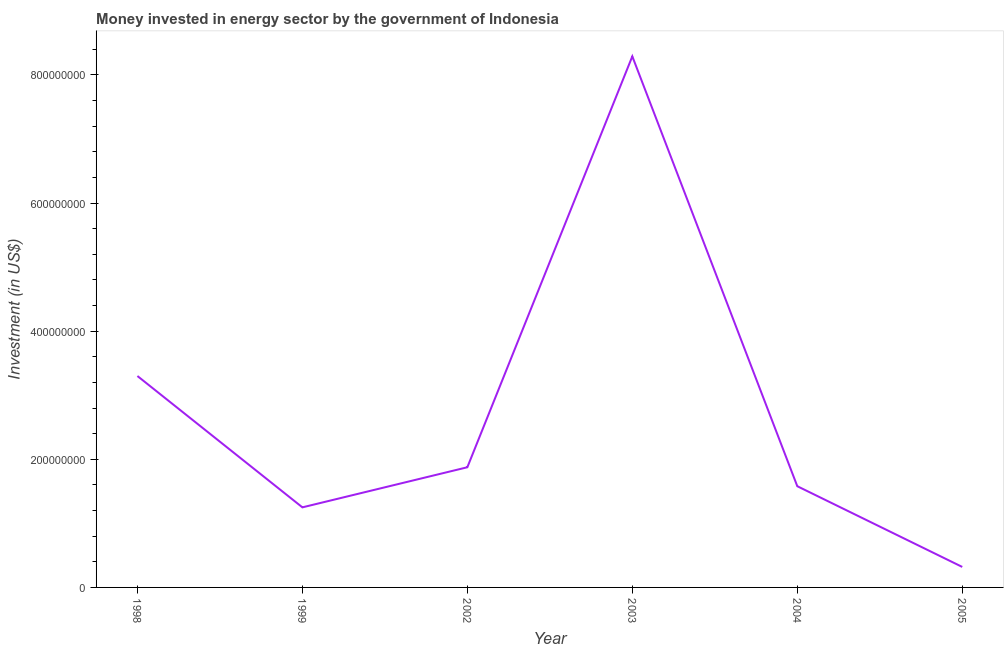What is the investment in energy in 1998?
Provide a short and direct response. 3.30e+08. Across all years, what is the maximum investment in energy?
Provide a short and direct response. 8.29e+08. Across all years, what is the minimum investment in energy?
Your answer should be very brief. 3.20e+07. What is the sum of the investment in energy?
Give a very brief answer. 1.66e+09. What is the difference between the investment in energy in 1998 and 1999?
Make the answer very short. 2.05e+08. What is the average investment in energy per year?
Your answer should be very brief. 2.77e+08. What is the median investment in energy?
Provide a succinct answer. 1.73e+08. Do a majority of the years between 1999 and 2004 (inclusive) have investment in energy greater than 600000000 US$?
Your answer should be compact. No. What is the ratio of the investment in energy in 2003 to that in 2004?
Keep it short and to the point. 5.25. Is the investment in energy in 2002 less than that in 2003?
Ensure brevity in your answer.  Yes. What is the difference between the highest and the second highest investment in energy?
Ensure brevity in your answer.  4.99e+08. What is the difference between the highest and the lowest investment in energy?
Provide a short and direct response. 7.97e+08. In how many years, is the investment in energy greater than the average investment in energy taken over all years?
Ensure brevity in your answer.  2. How many lines are there?
Your answer should be very brief. 1. How many years are there in the graph?
Keep it short and to the point. 6. Are the values on the major ticks of Y-axis written in scientific E-notation?
Provide a succinct answer. No. Does the graph contain any zero values?
Keep it short and to the point. No. Does the graph contain grids?
Give a very brief answer. No. What is the title of the graph?
Your answer should be compact. Money invested in energy sector by the government of Indonesia. What is the label or title of the Y-axis?
Your answer should be very brief. Investment (in US$). What is the Investment (in US$) in 1998?
Your response must be concise. 3.30e+08. What is the Investment (in US$) of 1999?
Your answer should be compact. 1.25e+08. What is the Investment (in US$) in 2002?
Keep it short and to the point. 1.88e+08. What is the Investment (in US$) of 2003?
Your response must be concise. 8.29e+08. What is the Investment (in US$) in 2004?
Keep it short and to the point. 1.58e+08. What is the Investment (in US$) of 2005?
Offer a terse response. 3.20e+07. What is the difference between the Investment (in US$) in 1998 and 1999?
Offer a very short reply. 2.05e+08. What is the difference between the Investment (in US$) in 1998 and 2002?
Ensure brevity in your answer.  1.42e+08. What is the difference between the Investment (in US$) in 1998 and 2003?
Offer a very short reply. -4.99e+08. What is the difference between the Investment (in US$) in 1998 and 2004?
Make the answer very short. 1.72e+08. What is the difference between the Investment (in US$) in 1998 and 2005?
Ensure brevity in your answer.  2.98e+08. What is the difference between the Investment (in US$) in 1999 and 2002?
Offer a very short reply. -6.26e+07. What is the difference between the Investment (in US$) in 1999 and 2003?
Your answer should be compact. -7.04e+08. What is the difference between the Investment (in US$) in 1999 and 2004?
Ensure brevity in your answer.  -3.30e+07. What is the difference between the Investment (in US$) in 1999 and 2005?
Make the answer very short. 9.30e+07. What is the difference between the Investment (in US$) in 2002 and 2003?
Provide a succinct answer. -6.41e+08. What is the difference between the Investment (in US$) in 2002 and 2004?
Ensure brevity in your answer.  2.96e+07. What is the difference between the Investment (in US$) in 2002 and 2005?
Provide a succinct answer. 1.56e+08. What is the difference between the Investment (in US$) in 2003 and 2004?
Ensure brevity in your answer.  6.71e+08. What is the difference between the Investment (in US$) in 2003 and 2005?
Offer a very short reply. 7.97e+08. What is the difference between the Investment (in US$) in 2004 and 2005?
Offer a terse response. 1.26e+08. What is the ratio of the Investment (in US$) in 1998 to that in 1999?
Give a very brief answer. 2.64. What is the ratio of the Investment (in US$) in 1998 to that in 2002?
Your response must be concise. 1.76. What is the ratio of the Investment (in US$) in 1998 to that in 2003?
Offer a very short reply. 0.4. What is the ratio of the Investment (in US$) in 1998 to that in 2004?
Give a very brief answer. 2.09. What is the ratio of the Investment (in US$) in 1998 to that in 2005?
Keep it short and to the point. 10.31. What is the ratio of the Investment (in US$) in 1999 to that in 2002?
Provide a short and direct response. 0.67. What is the ratio of the Investment (in US$) in 1999 to that in 2003?
Your response must be concise. 0.15. What is the ratio of the Investment (in US$) in 1999 to that in 2004?
Keep it short and to the point. 0.79. What is the ratio of the Investment (in US$) in 1999 to that in 2005?
Offer a terse response. 3.91. What is the ratio of the Investment (in US$) in 2002 to that in 2003?
Offer a very short reply. 0.23. What is the ratio of the Investment (in US$) in 2002 to that in 2004?
Ensure brevity in your answer.  1.19. What is the ratio of the Investment (in US$) in 2002 to that in 2005?
Offer a very short reply. 5.86. What is the ratio of the Investment (in US$) in 2003 to that in 2004?
Your response must be concise. 5.25. What is the ratio of the Investment (in US$) in 2003 to that in 2005?
Make the answer very short. 25.91. What is the ratio of the Investment (in US$) in 2004 to that in 2005?
Your answer should be very brief. 4.94. 